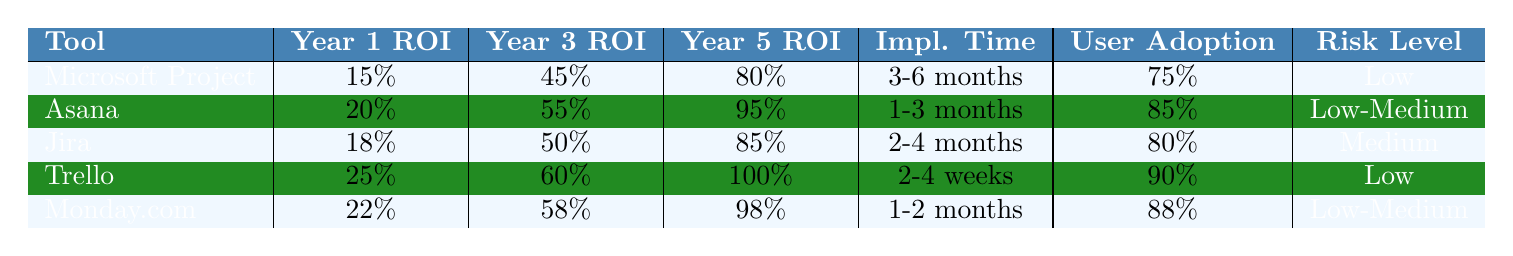What is the Year 3 ROI for Trello? From the table, we see that for Trello, the Year 3 ROI is listed clearly as 60%.
Answer: 60% Which project management tool has the highest Year 5 ROI? By comparing the Year 5 ROI values, we find that Trello has the highest ROI at 100%.
Answer: Trello What is the implementation time for Monday.com? The table indicates that the implementation time for Monday.com is 1-2 months.
Answer: 1-2 months Which tools have a low-risk level? The tools identified with a low-risk level from the table are Microsoft Project, Trello, and Monday.com.
Answer: Microsoft Project, Trello, and Monday.com Calculate the average Year 1 ROI of all tools. The Year 1 ROIs are 15%, 20%, 18%, 25%, and 22%. Summing these values gives 100%. Dividing by 5 tools results in an average of 20%.
Answer: 20% Is the user adoption rate for Asana higher than for Jira? By comparing user adoption rates, Asana has an 85% rate, while Jira has 80%. Therefore, Asana's user adoption rate is higher.
Answer: Yes If we consider project management tools with a medium to low risk, what is the highest Year 3 ROI among them? The tools with medium or low risk are Microsoft Project, Asana, Trello, and Monday.com. Their Year 3 ROIs are 45%, 55%, 60%, and 58%, respectively. The highest among these is Trello at 60%.
Answer: 60% Which tool has both the highest Year 1 ROI and the lowest implementation time? The Year 1 ROIs are 15% (Microsoft Project), 20% (Asana), 18% (Jira), 25% (Trello), and 22% (Monday.com). The implementation times are 3-6 months, 1-3 months, 2-4 months, 2-4 weeks, and 1-2 months, respectively. Trello has the highest Year 1 ROI at 25% and the implementation time of 2-4 weeks is the shortest among these tools.
Answer: Trello What percentage difference in Year 5 ROI exists between Jira and Monday.com? The Year 5 ROI for Jira is 85% and for Monday.com is 98%. The difference is 98% - 85% = 13%.
Answer: 13% 